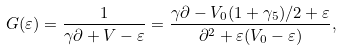Convert formula to latex. <formula><loc_0><loc_0><loc_500><loc_500>G ( \varepsilon ) = \frac { 1 } { \gamma \partial + V - \varepsilon } = \frac { \gamma \partial - V _ { 0 } ( 1 + \gamma _ { 5 } ) / 2 + \varepsilon } { \partial ^ { 2 } + \varepsilon ( V _ { 0 } - \varepsilon ) } ,</formula> 